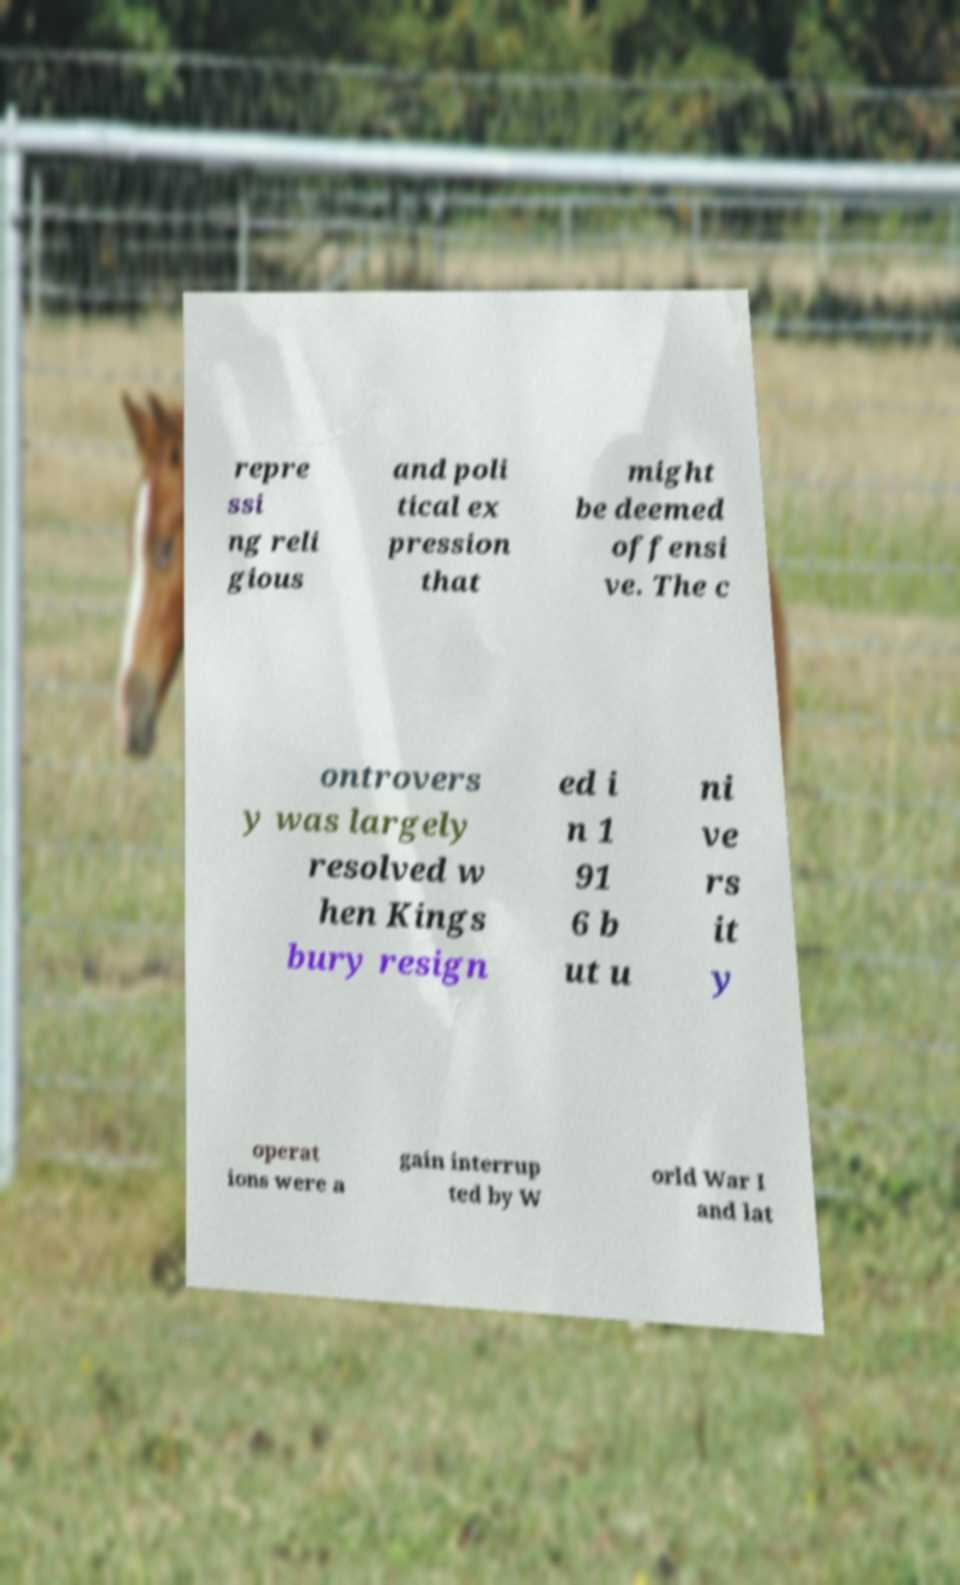Please read and relay the text visible in this image. What does it say? repre ssi ng reli gious and poli tical ex pression that might be deemed offensi ve. The c ontrovers y was largely resolved w hen Kings bury resign ed i n 1 91 6 b ut u ni ve rs it y operat ions were a gain interrup ted by W orld War I and lat 